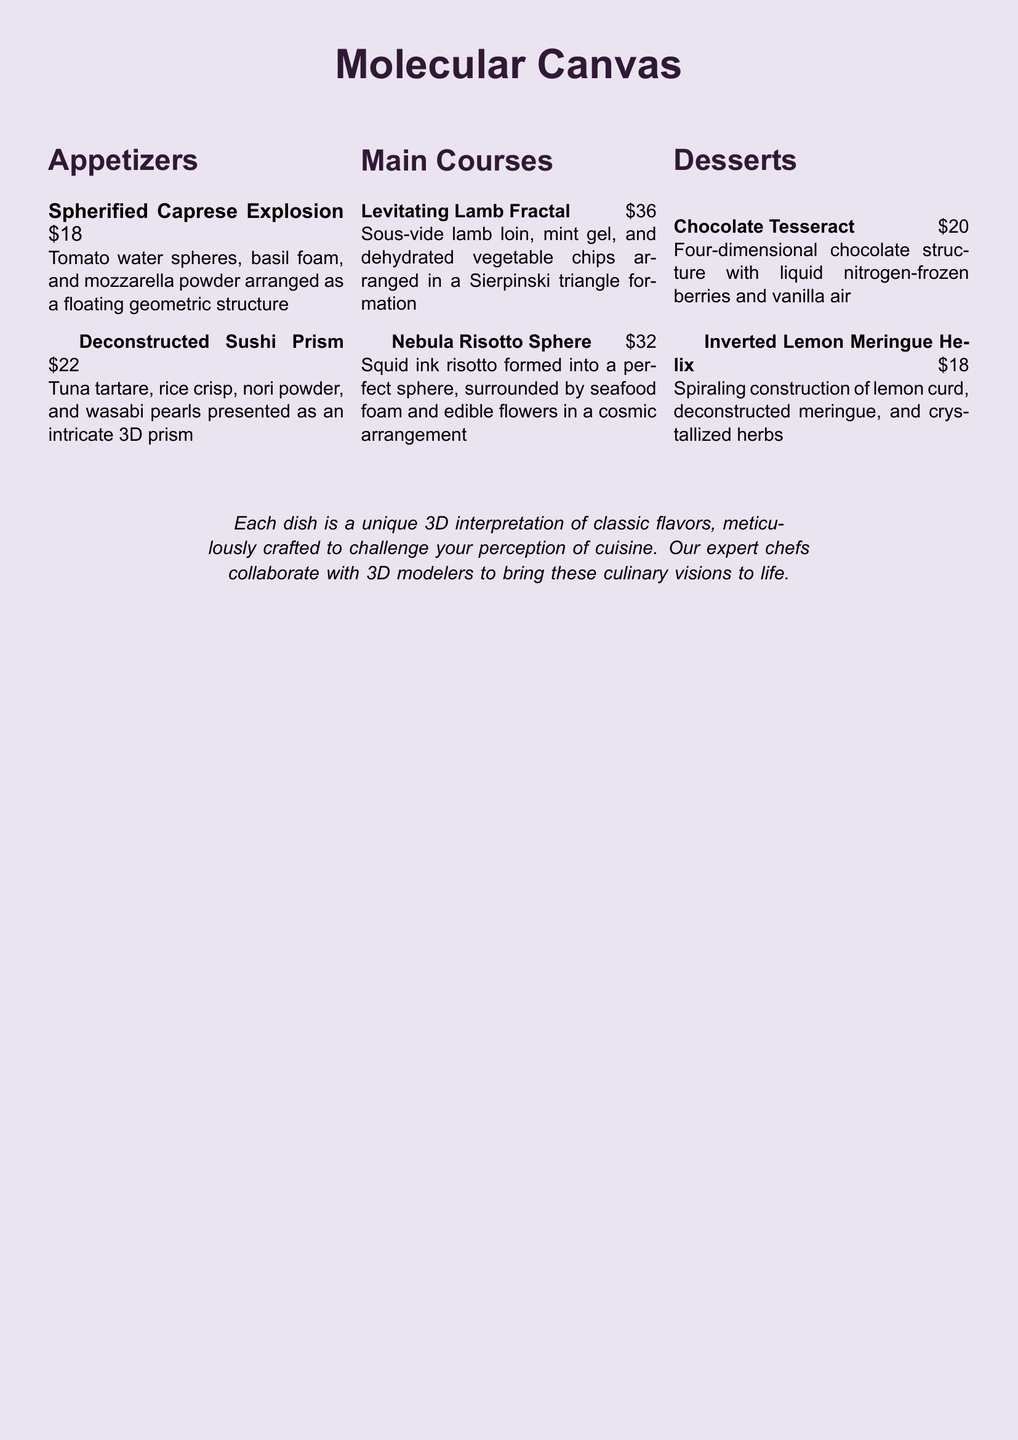What is the name of the first appetizer? The first appetizer listed is "Spherified Caprese Explosion."
Answer: Spherified Caprese Explosion How much does the Deconstructed Sushi Prism cost? The cost of the Deconstructed Sushi Prism is mentioned next to its title.
Answer: $22 What geometric shape is the Levitating Lamb Fractal arranged in? The arrangement of the Levitating Lamb Fractal is noted as a "Sierpinski triangle formation."
Answer: Sierpinski triangle Which dessert features a four-dimensional structure? The dessert described as having a four-dimensional structure is the "Chocolate Tesseract."
Answer: Chocolate Tesseract What is a key ingredient in the Nebula Risotto Sphere? A key ingredient mentioned for the Nebula Risotto Sphere is "squid ink risotto."
Answer: squid ink risotto How many appetizers are listed in the menu? The menu shows two appetizers in the appetizers section.
Answer: 2 What type of cuisine is emphasized in the document? The document emphasizes "molecular gastronomy" as the type of cuisine.
Answer: molecular gastronomy What is the unique aspect of the dishes mentioned? The dishes are described as "unique 3D interpretations of classic flavors."
Answer: unique 3D interpretations 